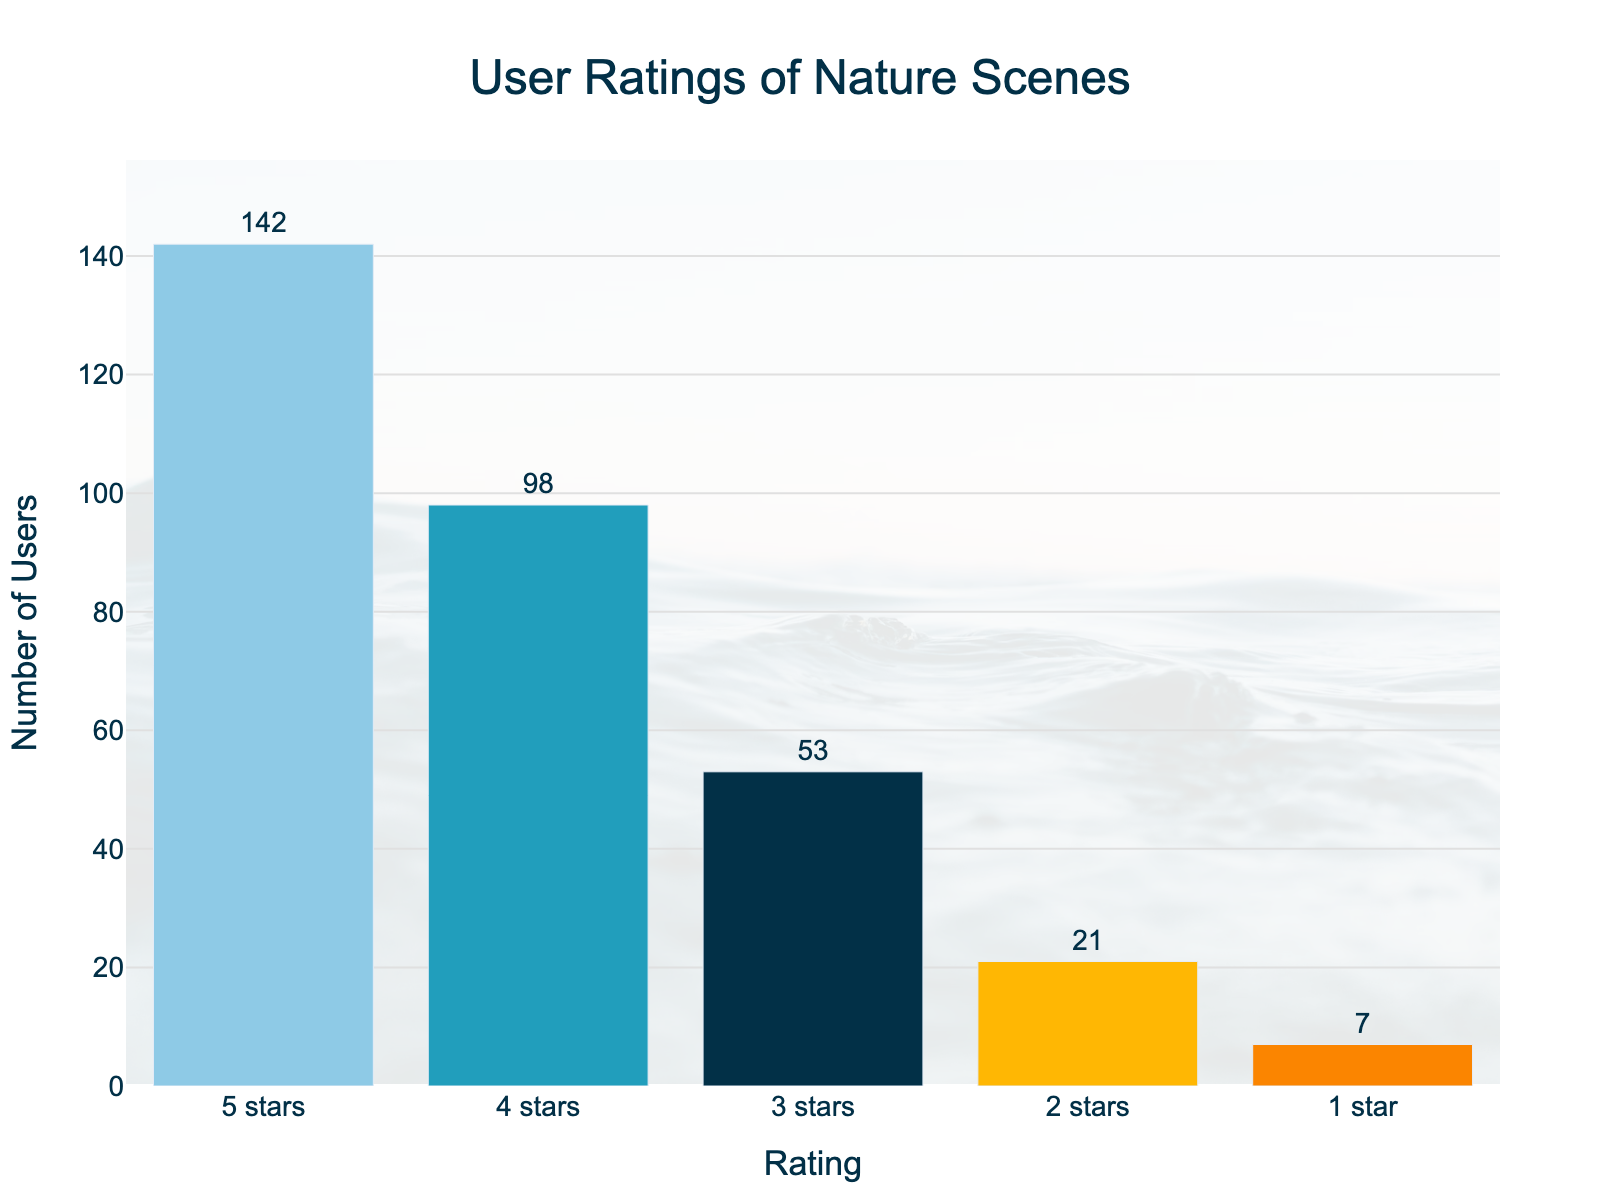What is the title of the figure? The title is prominently placed at the top center and reads 'User Ratings of Nature Scenes'
Answer: User Ratings of Nature Scenes How many ratings are logged with 1 star? The bar with the label '1 star' on the x-axis indicates 7 users, which is displayed directly on the top of that bar
Answer: 7 Which rating has the highest number of users? By observing the height of the bars and the text labels, the '5 stars' rating has the highest number of users, with 142 users
Answer: 5 stars What is the total number of user ratings? Summing up all the counts from the bars: 142 (5 stars) + 98 (4 stars) + 53 (3 stars) + 21 (2 stars) + 7 (1 star) = 321
Answer: 321 How many more users rated the scenes with 5 stars compared to 2 stars? The difference between the counts of '5 stars' (142) and '2 stars' (21) is 142 - 21 = 121
Answer: 121 How do the colors of the bars differ from each other? The colors of the bars range from light blue to dark blue, orange, and shades in between, specifically: the '5 stars' bar is light blue, '4 stars' slightly darker, '3 stars' is dark blue, '2 stars' is bright orange, and '1 star' is dark orange
Answer: Various shades of blue and orange What is the combined number of users who rated the scenes 4 or 5 stars? Adding the counts of '4 stars' (98) and '5 stars' (142) gives: 98 + 142 = 240
Answer: 240 Which rating has the fewest users, and how many? By looking at the bar with the smallest height, the '1 star' rating has the fewest users with a count of 7
Answer: 1 star, 7 What is the average number of users for each rating? The total number of users across all ratings is 321, and there are 5 ratings. The average is calculated as 321 / 5 = 64.2
Answer: 64.2 Compare the number of users who rated 3 stars to those who rated 4 stars. How many more or fewer users rated the scenes with 3 stars? The '3 stars' rating has 53 users, and '4 stars' has 98 users. The difference is 98 - 53 = 45 more users for 4 stars
Answer: 45 more users for 4 stars 